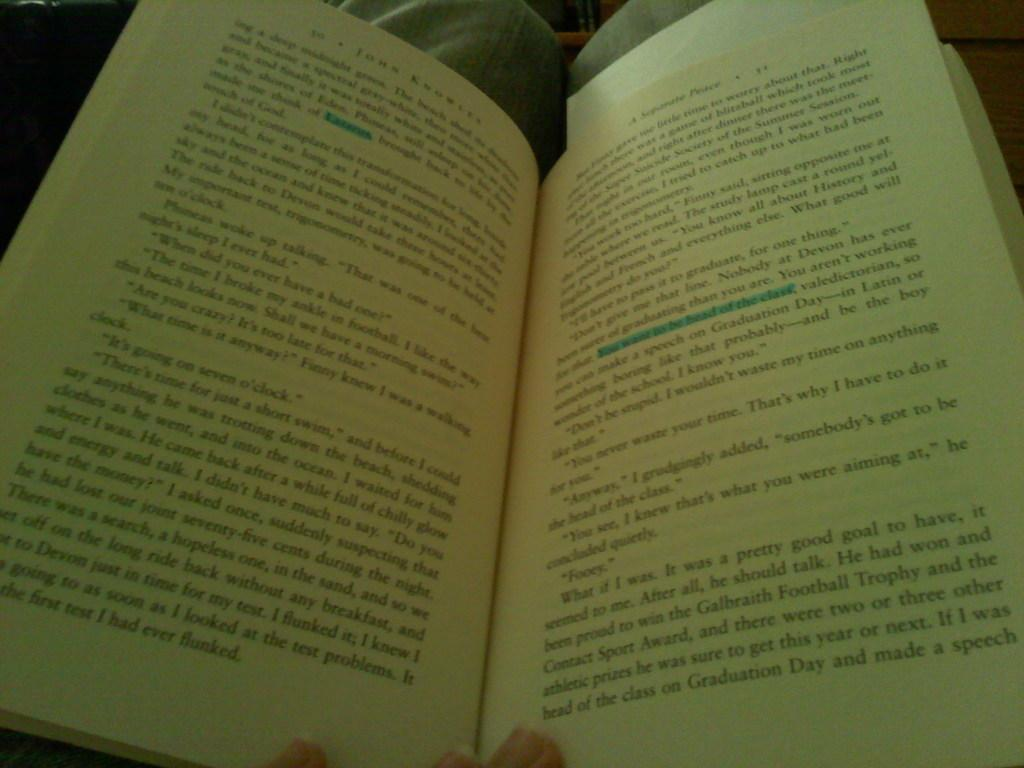<image>
Create a compact narrative representing the image presented. A John Knowles book is opened to a page with highlighted text on it. 